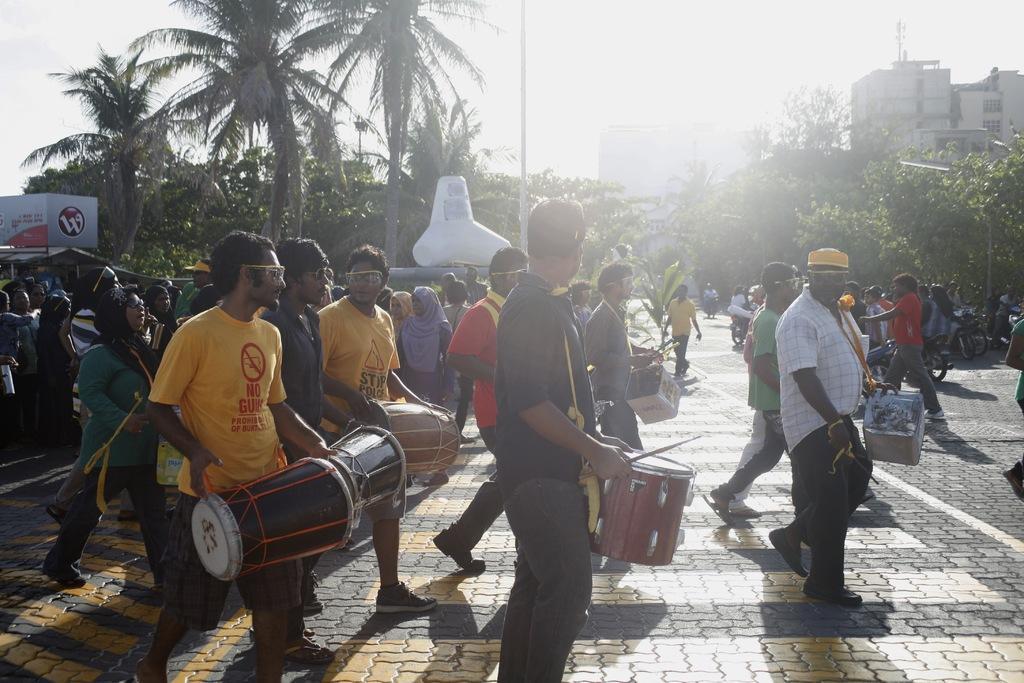In one or two sentences, can you explain what this image depicts? In this image there are many people. In the background there are trees, building and sky. On the right there is a person he wear shirt, trouser and shoe. 